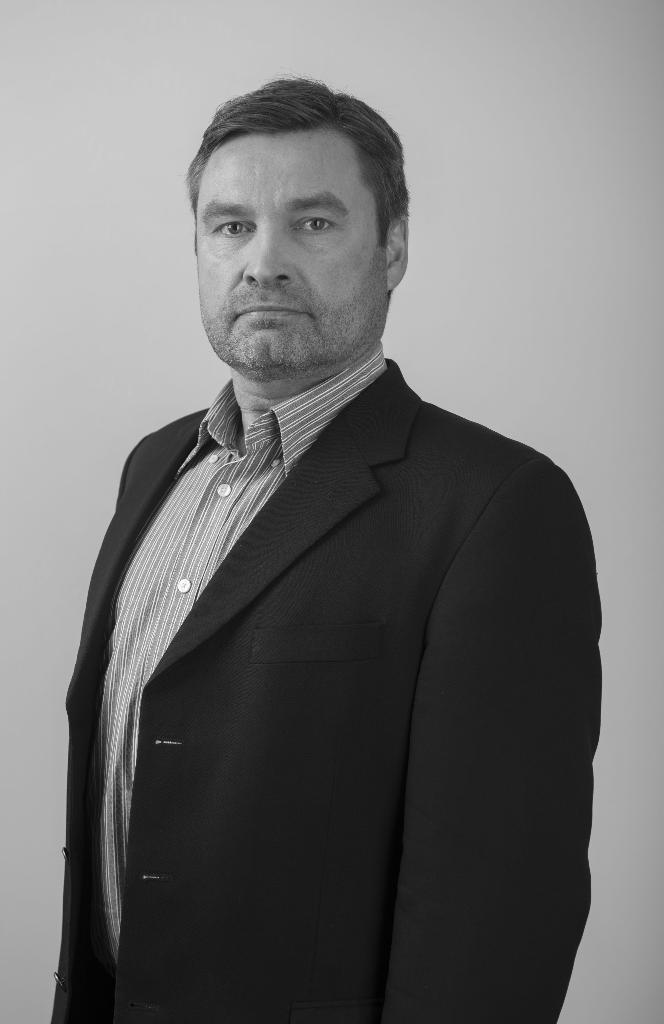Can you describe this image briefly? This is a black and white image. We can see a person and the background. 